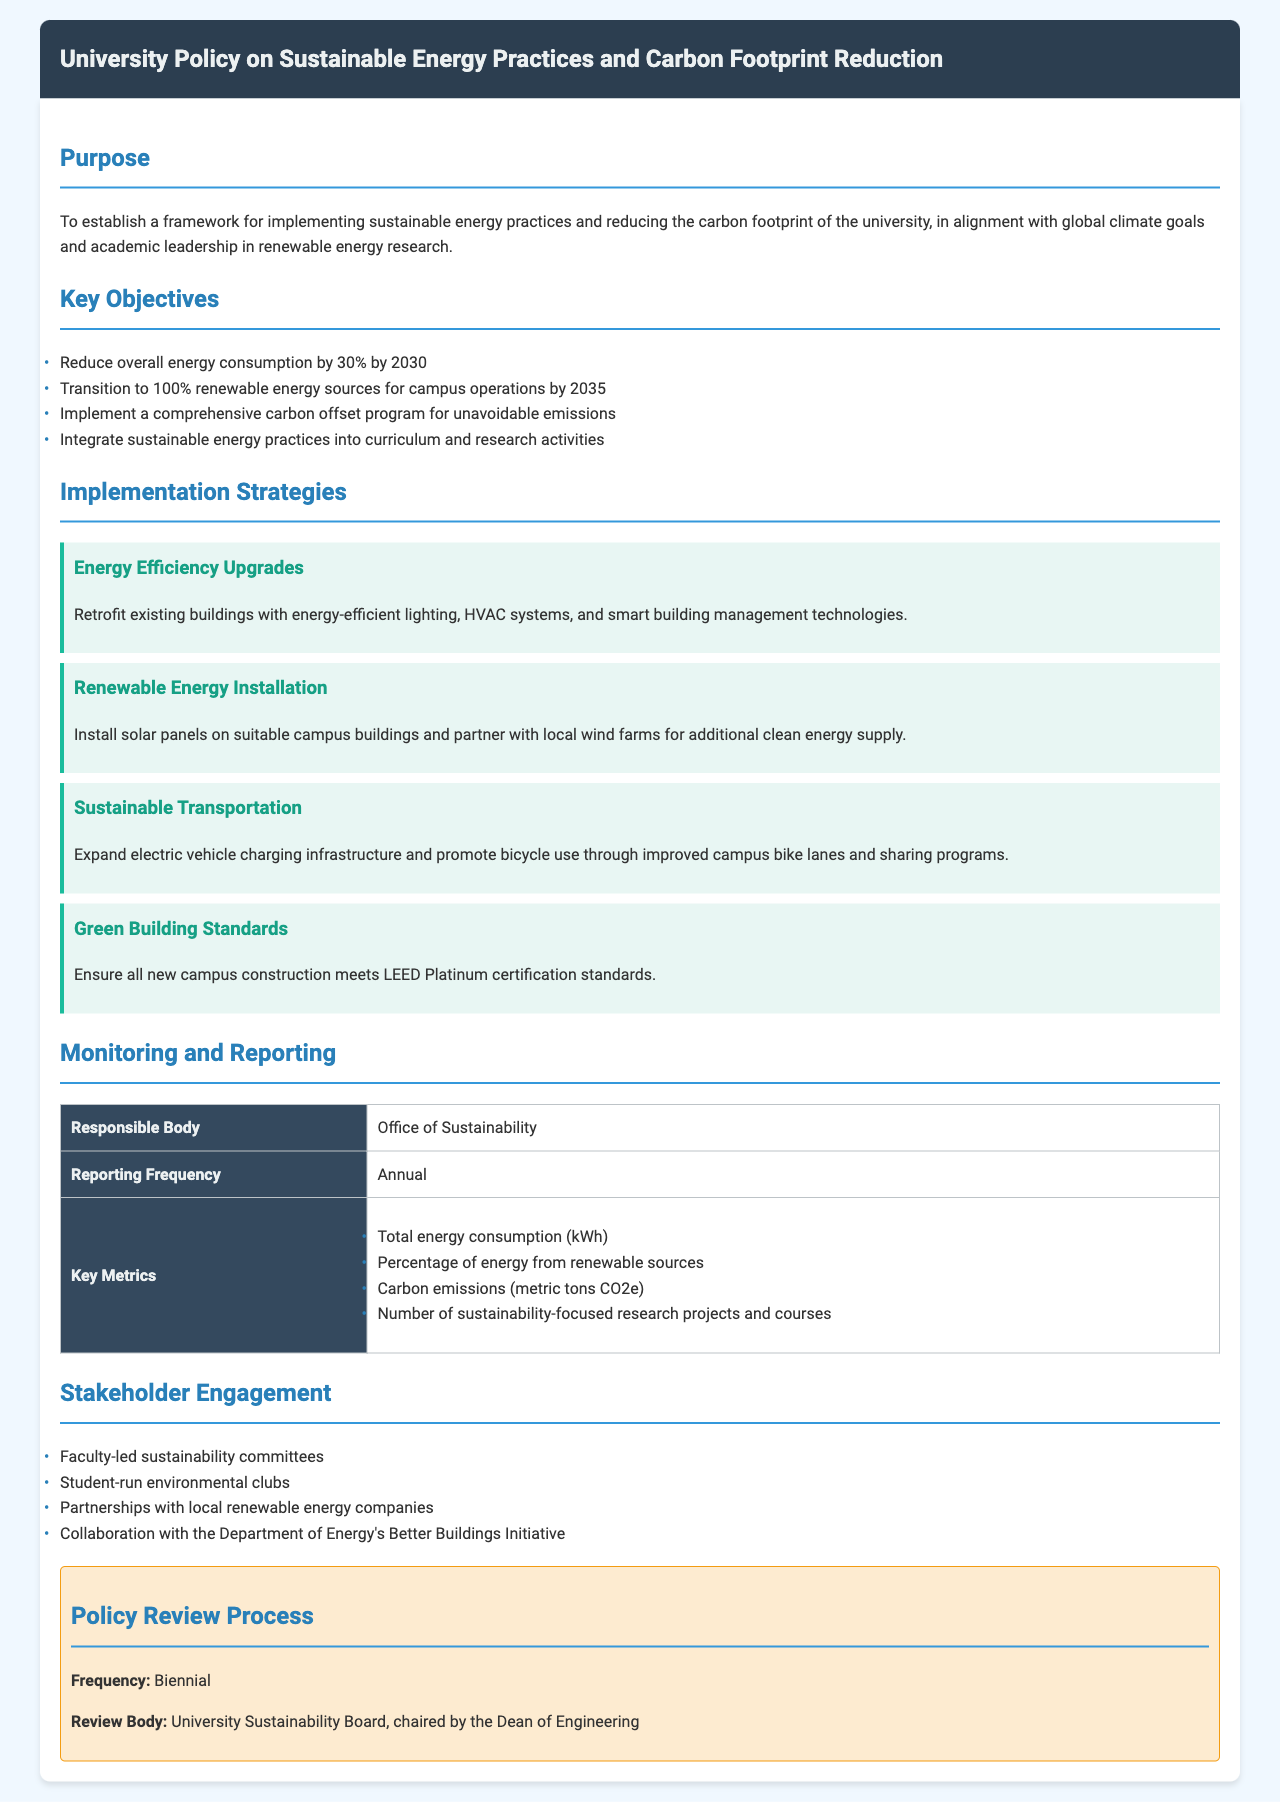What is the main purpose of the policy? The policy aims to establish a framework for sustainable energy practices and reducing carbon footprint in alignment with climate goals.
Answer: To establish a framework for implementing sustainable energy practices and reducing the carbon footprint of the university, in alignment with global climate goals and academic leadership in renewable energy research What is the target percentage reduction in overall energy consumption by 2030? The document states a specific reduction target that is a clear numerical goal.
Answer: 30% By when does the university aim for 100% renewable energy sources? The document highlights a deadline for achieving the transition to renewable energy, indicating a commitment to sustainability.
Answer: 2035 What body is responsible for monitoring and reporting? The document specifies the entity responsible for overseeing the implementation of the policy, ensuring accountability.
Answer: Office of Sustainability What are the key metrics reported annually? This question covers the metrics that are measured to evaluate progress and effectiveness outlined in the document.
Answer: Total energy consumption (kWh), Percentage of energy from renewable sources, Carbon emissions (metric tons CO2e), Number of sustainability-focused research projects and courses What certification standard must new campus construction meet? The document identifies a specific green building standard that reflects commitment to sustainability in construction.
Answer: LEED Platinum Who chairs the University Sustainability Board? This question asks for the leadership structure involved in the policy review process according to the document.
Answer: Dean of Engineering When does the policy review occur? The document specifies the frequency with which the policy will be reviewed, highlighting the importance of ongoing assessment.
Answer: Biennial 